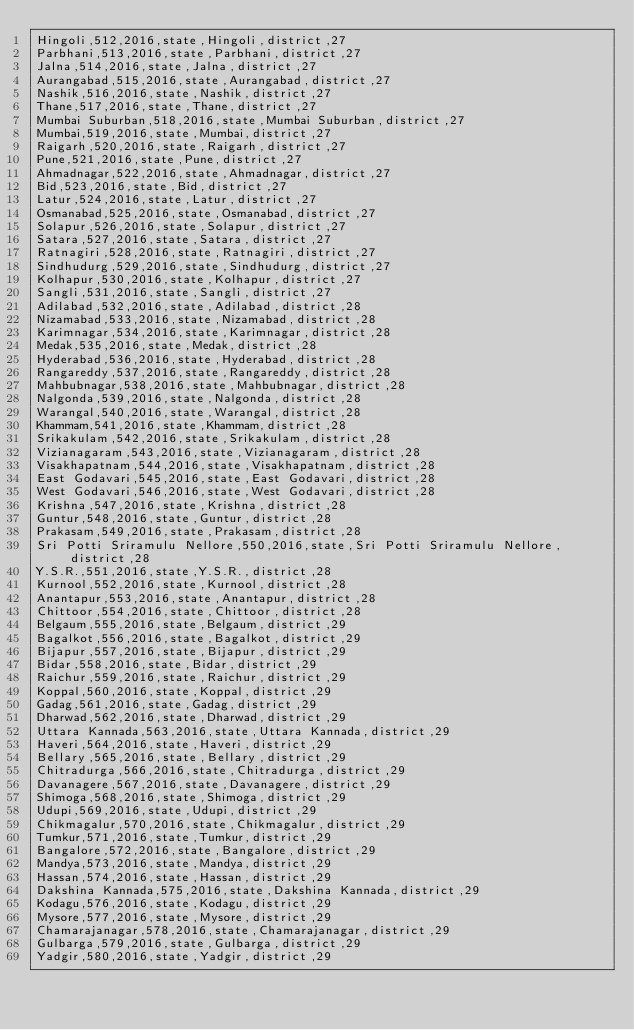<code> <loc_0><loc_0><loc_500><loc_500><_SQL_>Hingoli,512,2016,state,Hingoli,district,27
Parbhani,513,2016,state,Parbhani,district,27
Jalna,514,2016,state,Jalna,district,27
Aurangabad,515,2016,state,Aurangabad,district,27
Nashik,516,2016,state,Nashik,district,27
Thane,517,2016,state,Thane,district,27
Mumbai Suburban,518,2016,state,Mumbai Suburban,district,27
Mumbai,519,2016,state,Mumbai,district,27
Raigarh,520,2016,state,Raigarh,district,27
Pune,521,2016,state,Pune,district,27
Ahmadnagar,522,2016,state,Ahmadnagar,district,27
Bid,523,2016,state,Bid,district,27
Latur,524,2016,state,Latur,district,27
Osmanabad,525,2016,state,Osmanabad,district,27
Solapur,526,2016,state,Solapur,district,27
Satara,527,2016,state,Satara,district,27
Ratnagiri,528,2016,state,Ratnagiri,district,27
Sindhudurg,529,2016,state,Sindhudurg,district,27
Kolhapur,530,2016,state,Kolhapur,district,27
Sangli,531,2016,state,Sangli,district,27
Adilabad,532,2016,state,Adilabad,district,28
Nizamabad,533,2016,state,Nizamabad,district,28
Karimnagar,534,2016,state,Karimnagar,district,28
Medak,535,2016,state,Medak,district,28
Hyderabad,536,2016,state,Hyderabad,district,28
Rangareddy,537,2016,state,Rangareddy,district,28
Mahbubnagar,538,2016,state,Mahbubnagar,district,28
Nalgonda,539,2016,state,Nalgonda,district,28
Warangal,540,2016,state,Warangal,district,28
Khammam,541,2016,state,Khammam,district,28
Srikakulam,542,2016,state,Srikakulam,district,28
Vizianagaram,543,2016,state,Vizianagaram,district,28
Visakhapatnam,544,2016,state,Visakhapatnam,district,28
East Godavari,545,2016,state,East Godavari,district,28
West Godavari,546,2016,state,West Godavari,district,28
Krishna,547,2016,state,Krishna,district,28
Guntur,548,2016,state,Guntur,district,28
Prakasam,549,2016,state,Prakasam,district,28
Sri Potti Sriramulu Nellore,550,2016,state,Sri Potti Sriramulu Nellore,district,28
Y.S.R.,551,2016,state,Y.S.R.,district,28
Kurnool,552,2016,state,Kurnool,district,28
Anantapur,553,2016,state,Anantapur,district,28
Chittoor,554,2016,state,Chittoor,district,28
Belgaum,555,2016,state,Belgaum,district,29
Bagalkot,556,2016,state,Bagalkot,district,29
Bijapur,557,2016,state,Bijapur,district,29
Bidar,558,2016,state,Bidar,district,29
Raichur,559,2016,state,Raichur,district,29
Koppal,560,2016,state,Koppal,district,29
Gadag,561,2016,state,Gadag,district,29
Dharwad,562,2016,state,Dharwad,district,29
Uttara Kannada,563,2016,state,Uttara Kannada,district,29
Haveri,564,2016,state,Haveri,district,29
Bellary,565,2016,state,Bellary,district,29
Chitradurga,566,2016,state,Chitradurga,district,29
Davanagere,567,2016,state,Davanagere,district,29
Shimoga,568,2016,state,Shimoga,district,29
Udupi,569,2016,state,Udupi,district,29
Chikmagalur,570,2016,state,Chikmagalur,district,29
Tumkur,571,2016,state,Tumkur,district,29
Bangalore,572,2016,state,Bangalore,district,29
Mandya,573,2016,state,Mandya,district,29
Hassan,574,2016,state,Hassan,district,29
Dakshina Kannada,575,2016,state,Dakshina Kannada,district,29
Kodagu,576,2016,state,Kodagu,district,29
Mysore,577,2016,state,Mysore,district,29
Chamarajanagar,578,2016,state,Chamarajanagar,district,29
Gulbarga,579,2016,state,Gulbarga,district,29
Yadgir,580,2016,state,Yadgir,district,29</code> 